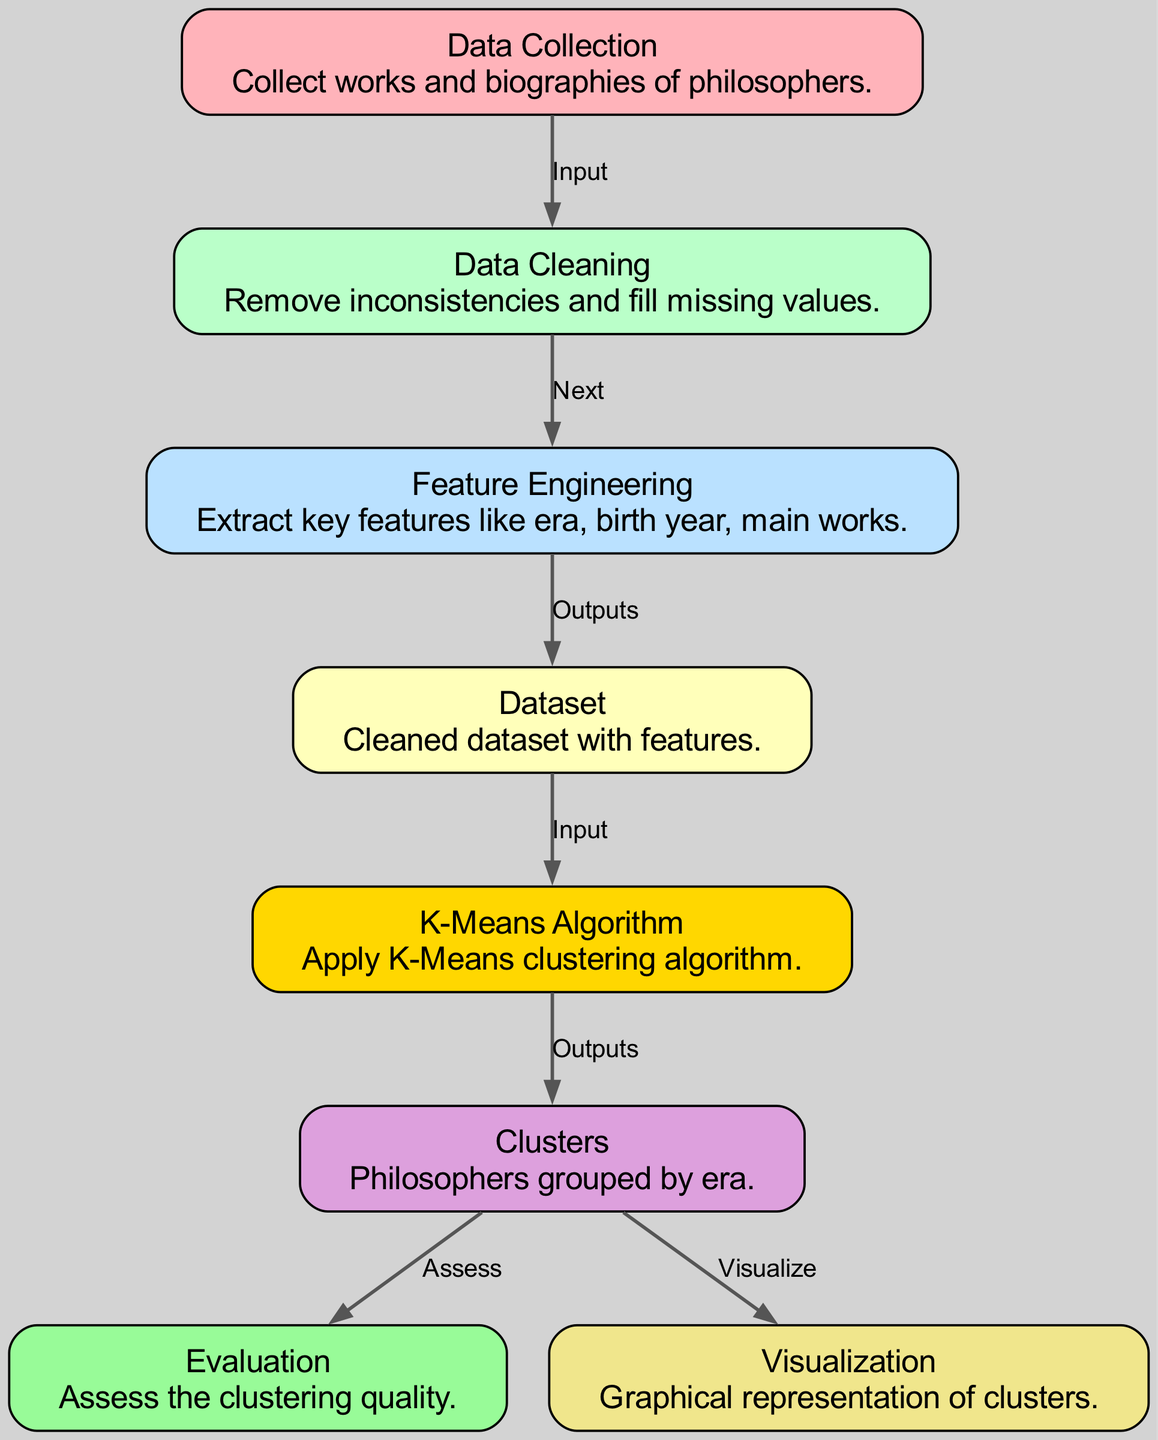What is the first step in the diagram? The first step is "Data Collection," which is the initial process where works and biographies of philosophers are gathered.
Answer: Data Collection How many nodes are there in the diagram? By counting all the listed nodes, we find that there are eight nodes in total, representing different stages in the clustering process.
Answer: 8 Which node outputs to the "K-Means Algorithm"? The node that outputs to the "K-Means Algorithm" is "Dataset," as indicated in the diagram's flow where the cleaned dataset provides input to this step.
Answer: Dataset What is the final output of the K-Means process? The final output of the K-Means process is "Clusters," which groups philosophers by era based on the applied clustering algorithm.
Answer: Clusters Which node visualizes the results of the clustering? The node that visualizes the results of the clustering is "Visualization," showing how the groups of philosophers are represented graphically.
Answer: Visualization What is the purpose of the "Evaluation" node? The purpose of the "Evaluation" node is to assess the quality of the clusters formed by the K-Means algorithm, ensuring that the grouping is meaningful.
Answer: Assess the clustering quality Which nodes are involved in the transition from data input to output? The nodes involved in this transition are "Data Cleaning," "Feature Engineering," and "Dataset," as they sequentially prepare the data before clustering begins.
Answer: Data Cleaning, Feature Engineering, Dataset What color represents the "K-Means Algorithm" node? The "K-Means Algorithm" node is represented in gold, indicating its importance in the data processing sequence.
Answer: Gold What relationship does "Clusters" have with "Evaluation" and "Visualization"? The "Clusters" node has a direct relationship with both "Evaluation" and "Visualization" as it outputs its results to both, allowing for quality assessment and graphical representation.
Answer: Assess and Visualize 